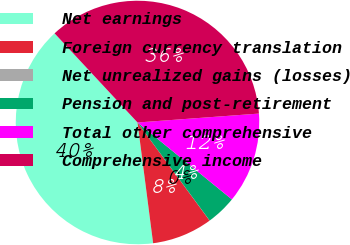Convert chart to OTSL. <chart><loc_0><loc_0><loc_500><loc_500><pie_chart><fcel>Net earnings<fcel>Foreign currency translation<fcel>Net unrealized gains (losses)<fcel>Pension and post-retirement<fcel>Total other comprehensive<fcel>Comprehensive income<nl><fcel>40.12%<fcel>8.04%<fcel>0.01%<fcel>4.02%<fcel>12.05%<fcel>35.76%<nl></chart> 